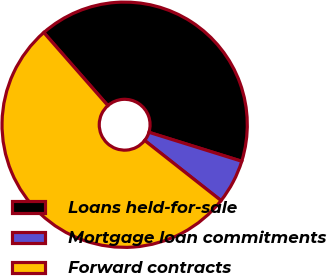Convert chart. <chart><loc_0><loc_0><loc_500><loc_500><pie_chart><fcel>Loans held-for-sale<fcel>Mortgage loan commitments<fcel>Forward contracts<nl><fcel>41.28%<fcel>5.8%<fcel>52.93%<nl></chart> 